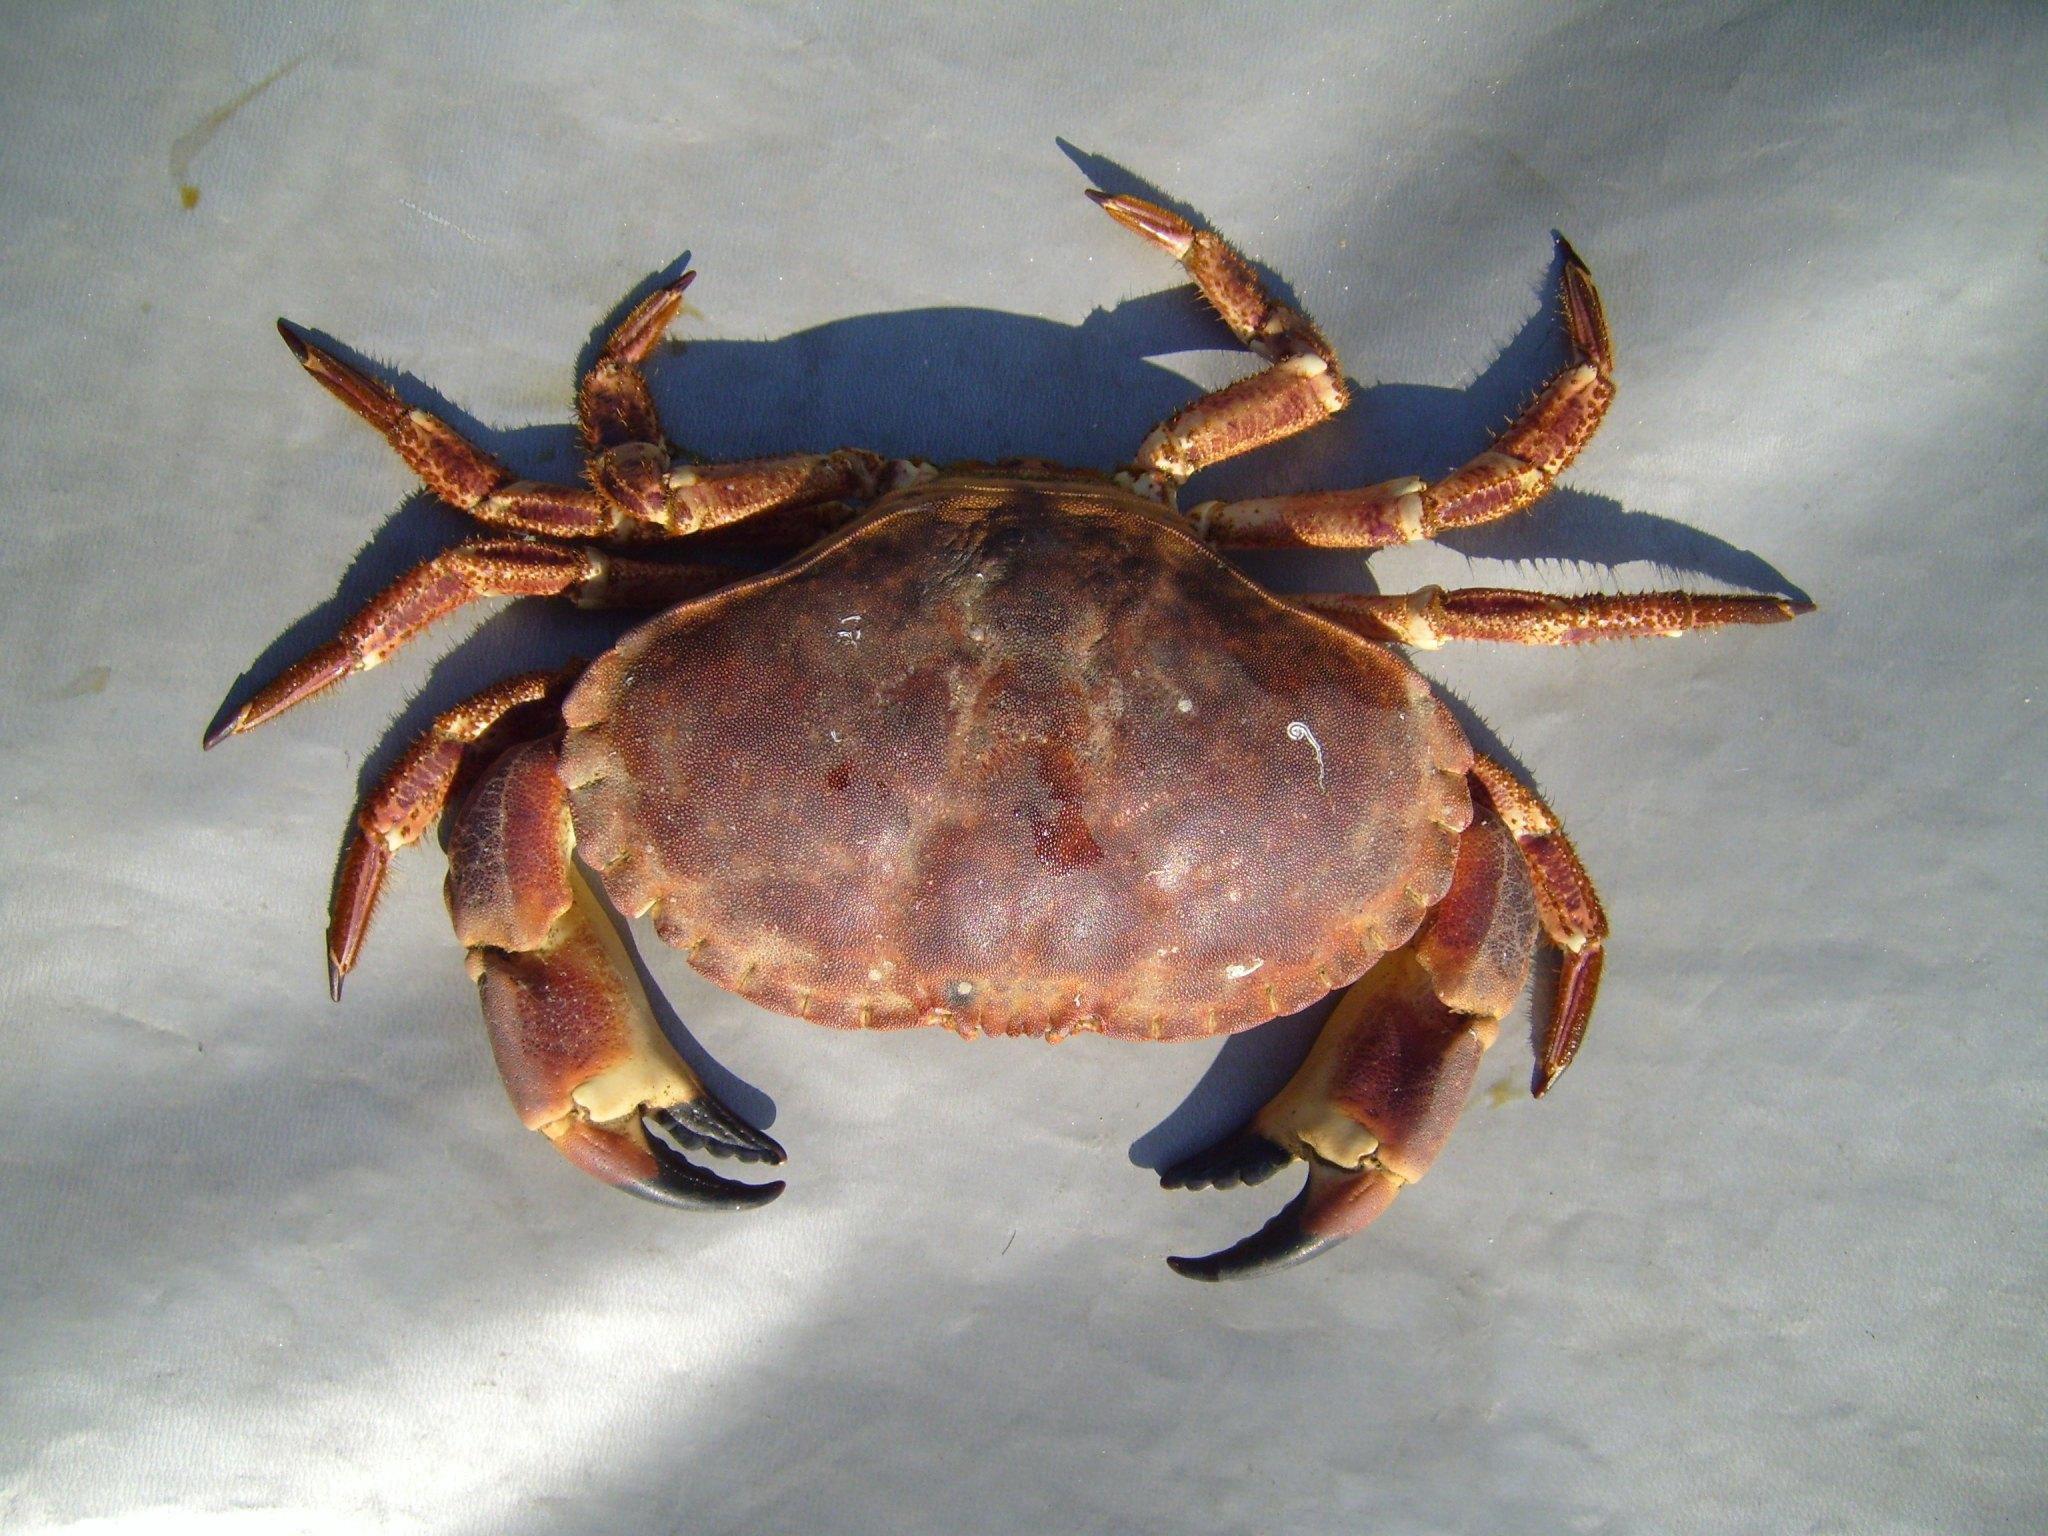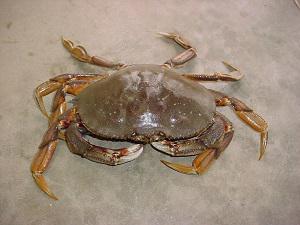The first image is the image on the left, the second image is the image on the right. Examine the images to the left and right. Is the description "Each image is a top-view of a crab with its face positioned at the bottom, and the crab on the left is more purplish and with black-tipped front claws, while the crab on the right is grayer." accurate? Answer yes or no. Yes. 